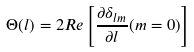Convert formula to latex. <formula><loc_0><loc_0><loc_500><loc_500>\Theta ( l ) = 2 R e \left [ \frac { \partial \delta _ { l m } } { \partial l } ( m = 0 ) \right ]</formula> 